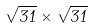<formula> <loc_0><loc_0><loc_500><loc_500>\sqrt { 3 1 } \times \sqrt { 3 1 }</formula> 